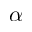Convert formula to latex. <formula><loc_0><loc_0><loc_500><loc_500>\alpha</formula> 